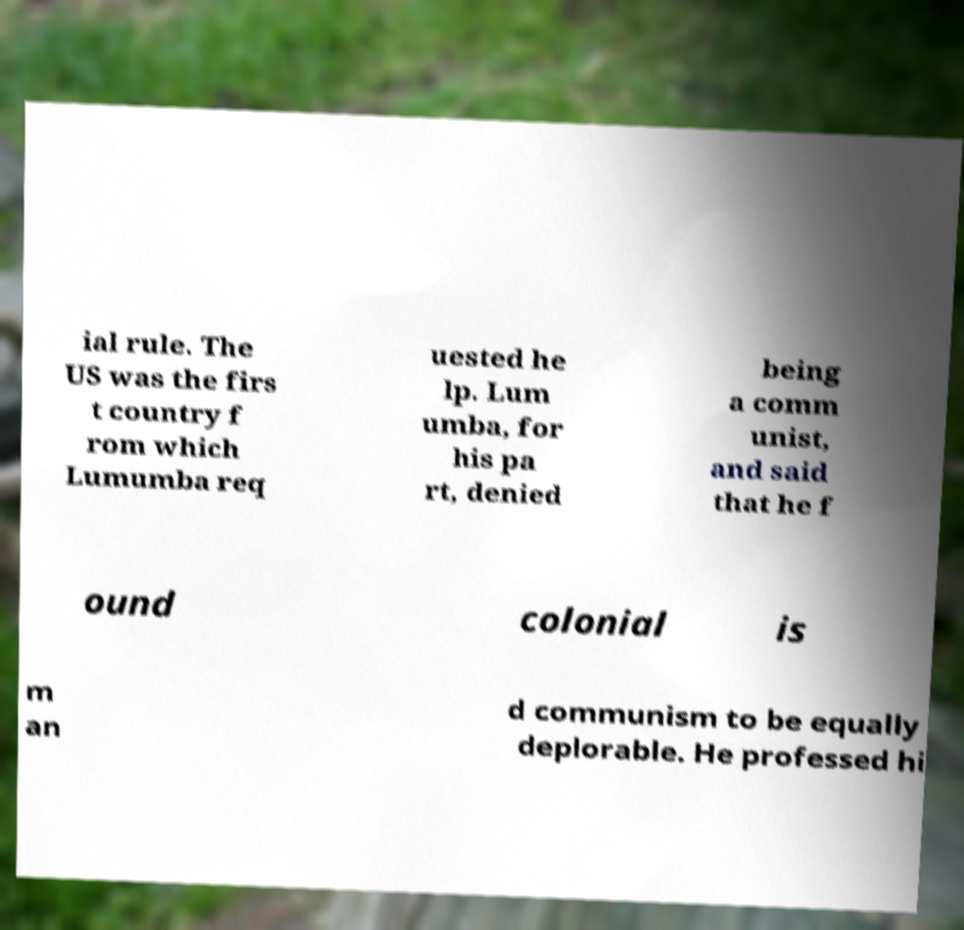Can you accurately transcribe the text from the provided image for me? ial rule. The US was the firs t country f rom which Lumumba req uested he lp. Lum umba, for his pa rt, denied being a comm unist, and said that he f ound colonial is m an d communism to be equally deplorable. He professed hi 